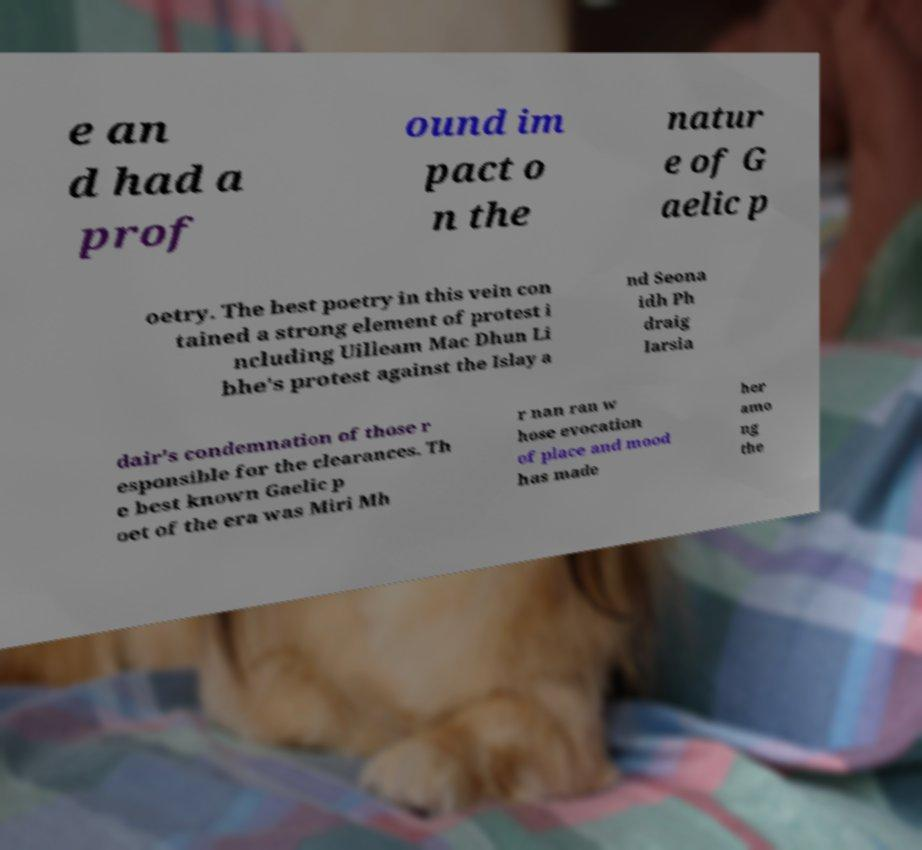Can you read and provide the text displayed in the image?This photo seems to have some interesting text. Can you extract and type it out for me? e an d had a prof ound im pact o n the natur e of G aelic p oetry. The best poetry in this vein con tained a strong element of protest i ncluding Uilleam Mac Dhun Li bhe's protest against the Islay a nd Seona idh Ph draig Iarsia dair's condemnation of those r esponsible for the clearances. Th e best known Gaelic p oet of the era was Miri Mh r nan ran w hose evocation of place and mood has made her amo ng the 